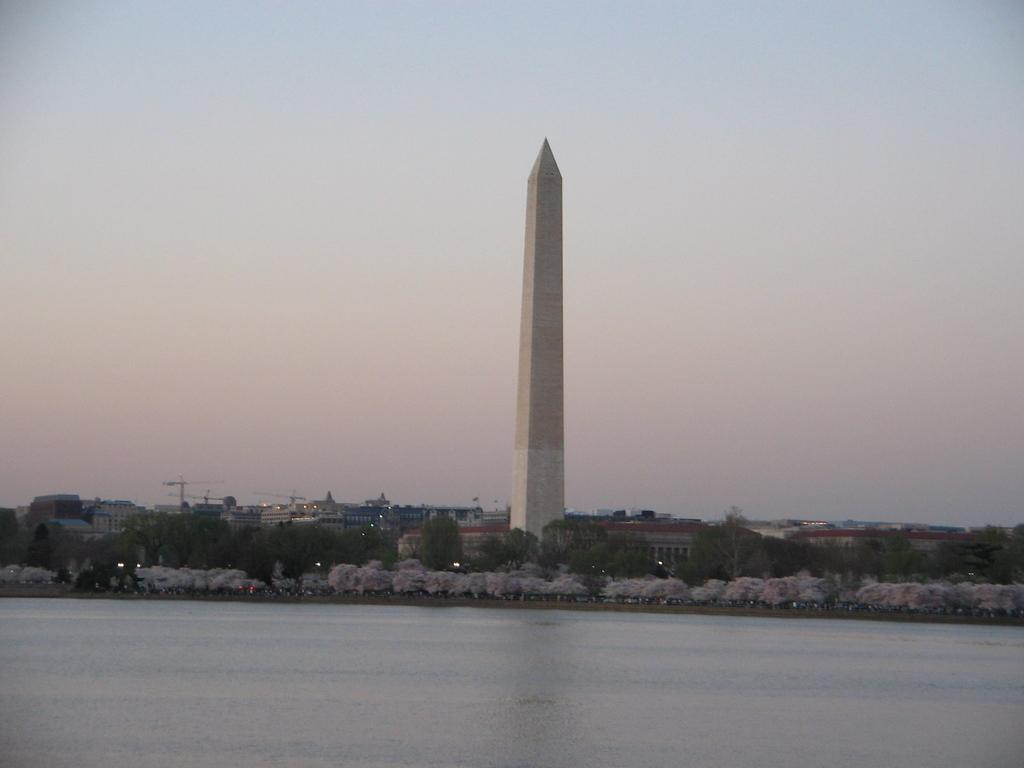What is the primary element visible in the image? There is water in the image. What type of vegetation can be seen in the image? There are trees in the image. What structure is present in the image? There is a tower in the image. What type of architecture is visible in the background of the image? There are buildings in the background of the image. What type of machinery is visible in the background of the image? There are cranes in the background of the image. What is visible in the sky in the background of the image? The sky is visible in the background of the image. What type of paint is being used by the turkey in the image? There is no turkey present in the image, and therefore no paint or painting activity can be observed. What type of skirt is being worn by the person in the image? There is no person present in the image, and therefore no skirt or clothing can be observed. 